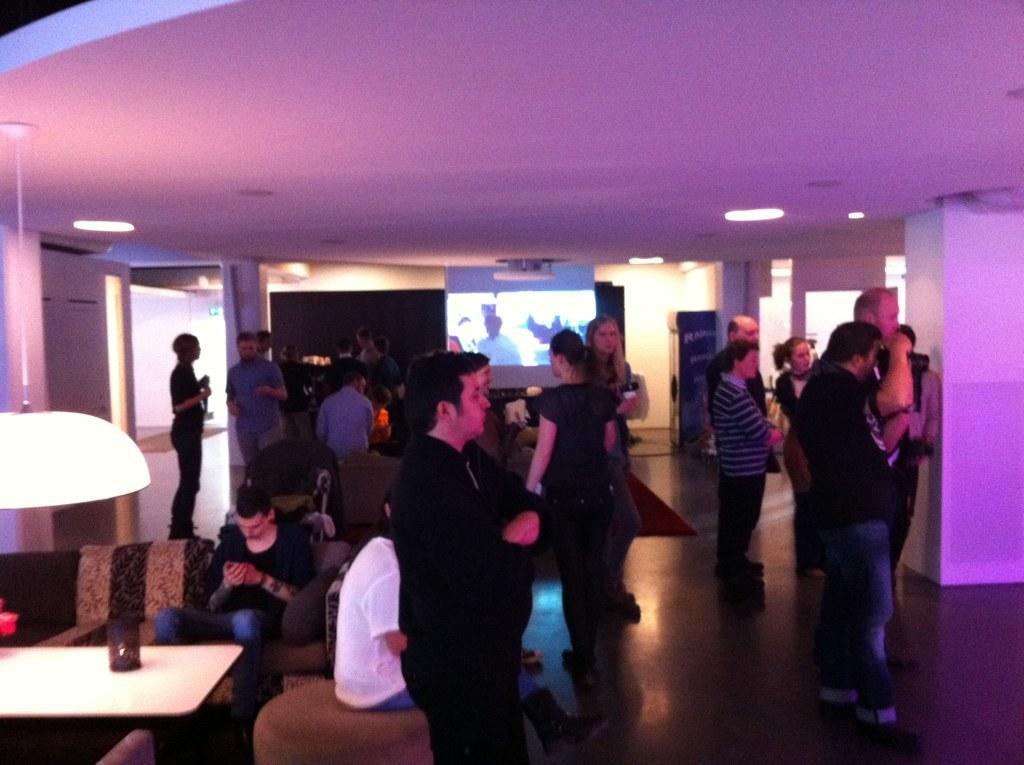Can you describe this image briefly? In this image I can see a group of people among them few are sitting on a sofa and few are standing on the floor. I can also see there is a projector screen and white color table. 